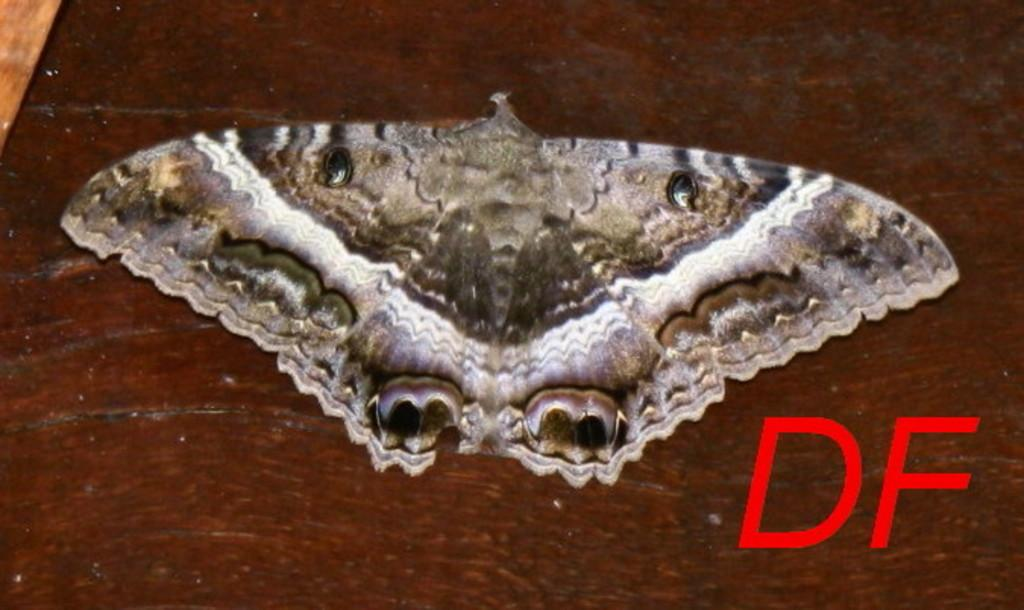What type of animal can be seen in the image? There is a butterfly in the image. What else is present on the floor in the image? There is text on the floor in the image. Can you describe the setting of the image? The image might have been taken in a room. What type of dog is sitting next to the queen in the image? There is no dog or queen present in the image; it features a butterfly and text on the floor. 